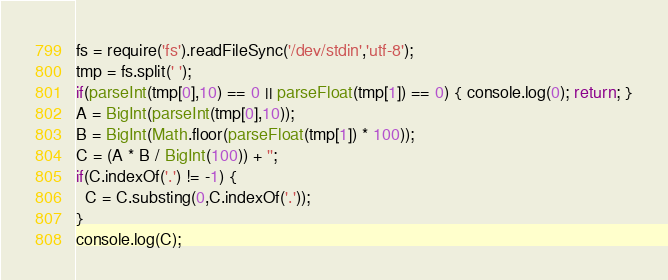Convert code to text. <code><loc_0><loc_0><loc_500><loc_500><_JavaScript_>fs = require('fs').readFileSync('/dev/stdin','utf-8');
tmp = fs.split(' ');
if(parseInt(tmp[0],10) == 0 || parseFloat(tmp[1]) == 0) { console.log(0); return; }
A = BigInt(parseInt(tmp[0],10));
B = BigInt(Math.floor(parseFloat(tmp[1]) * 100));
C = (A * B / BigInt(100)) + '';
if(C.indexOf('.') != -1) {
  C = C.substing(0,C.indexOf('.'));
}
console.log(C);
</code> 